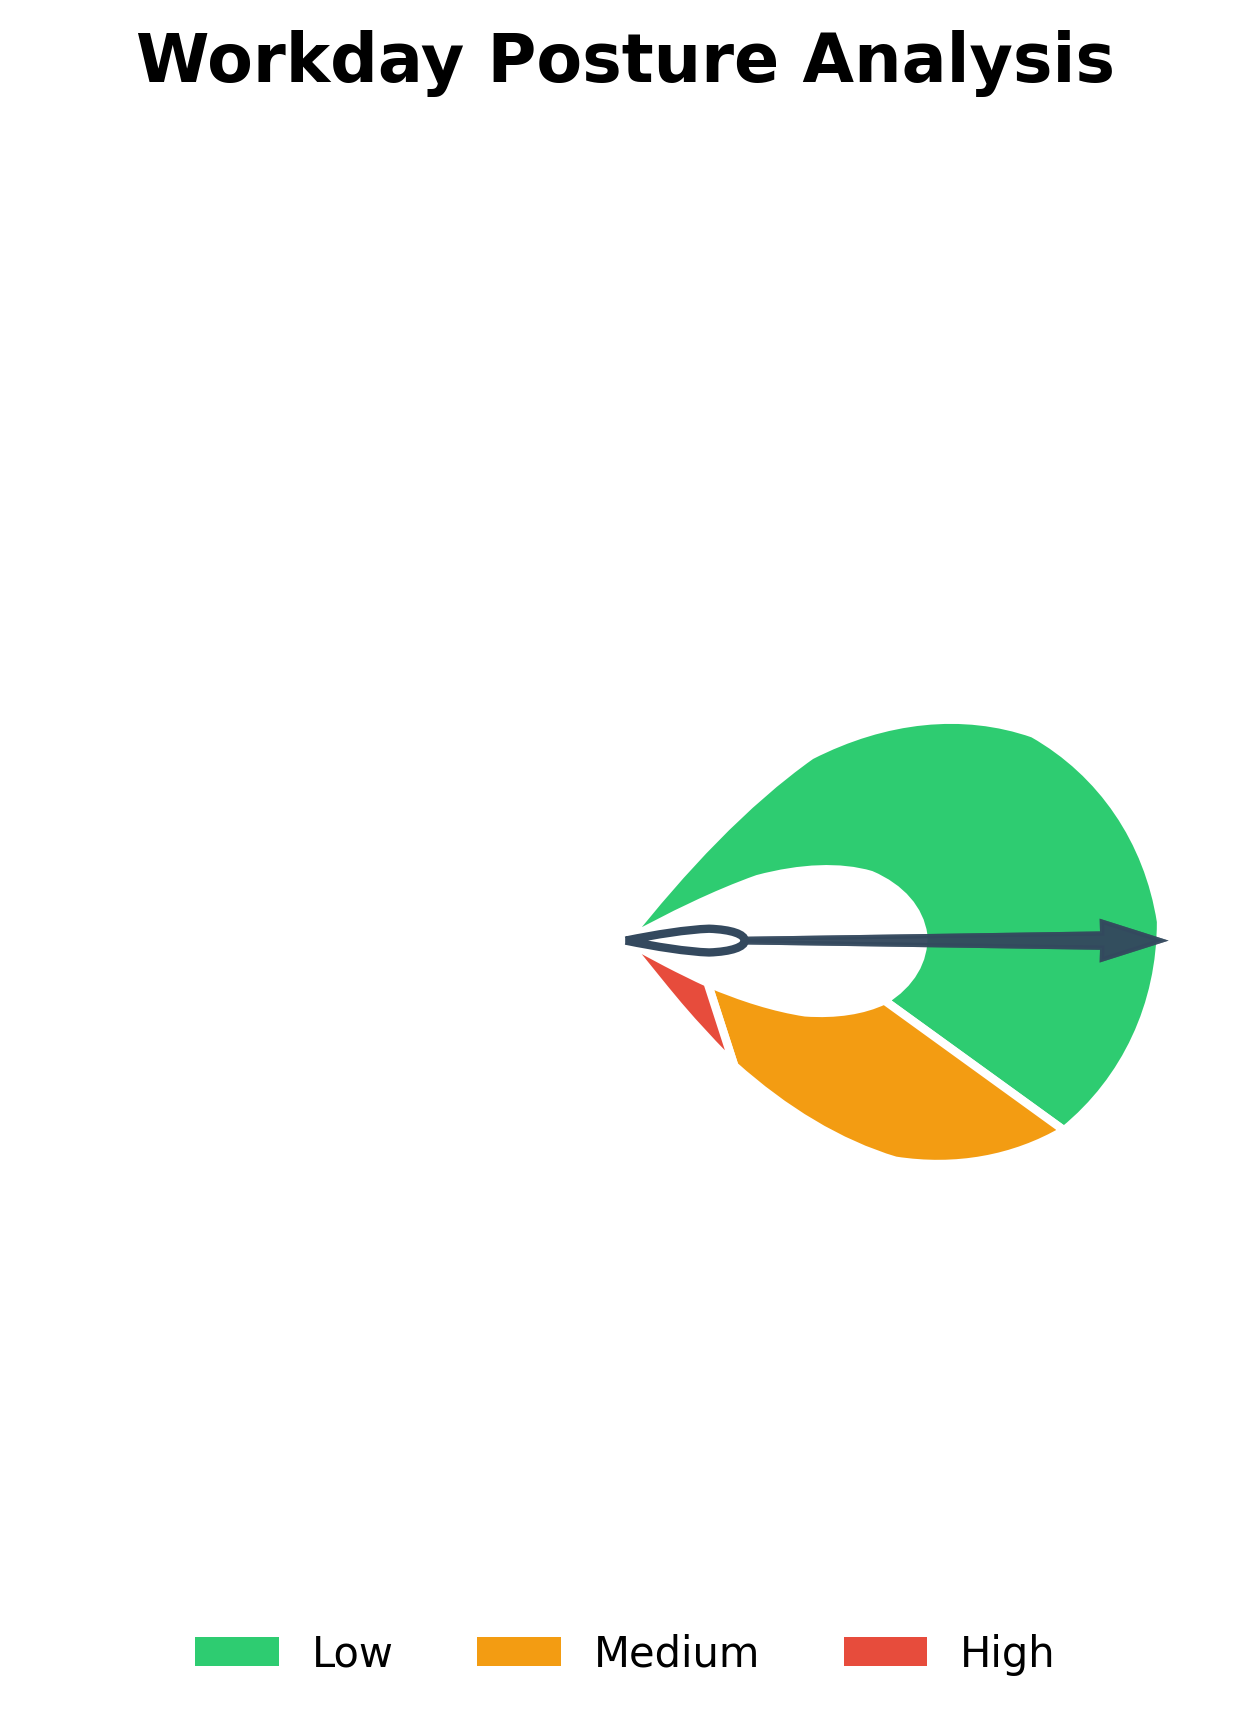What's the title of the gauge chart? The title of the chart is located at the top and reads "Workday Posture Analysis".
Answer: Workday Posture Analysis What percentage of the workday is spent sitting with good posture? The section labeled "Sitting with good posture" indicates the percentage directly beneath it.
Answer: 65% What color represents the high-risk zone? The high-risk zone is indicated by the color associated with the "High" label in the legend, which is red.
Answer: Red Which posture category has the lowest percentage? The need to compare all percentages. "Severe slouching" has the lowest percentage at 10%.
Answer: Severe slouching What is the combined percentage for the workday spent in moderate or severe slouching? Add the percentages for "Moderate slouching" and "Severe slouching": 25% + 10% = 35%.
Answer: 35% How many different risk levels are indicated in the chart? The chart's legend categorizes risk into three levels: Low, Medium, and High.
Answer: 3 Which posture category falls within the medium-risk zone? The legend and the medium-risk orange wedge indicate that "Moderate slouching" falls into this category.
Answer: Moderate slouching What percentage is allocated to the medium-risk zone? Locate the medium-risk zone and read the percentage associated with "Moderate slouching", which is 25%.
Answer: 25% How does the time spent in a low-risk posture compare to the combined time spent in other postures? Compare 65% (low-risk) to 35% (combined of medium and high risk: 25% + 10%). 65% is greater than 35%.
Answer: Greater If I improve my posture to sit with good posture for 5% more of my day, what would be the new percentage for sitting with good posture? Add the 5% increase to the current sitting with good posture percentage: 65% + 5% = 70%.
Answer: 70% 